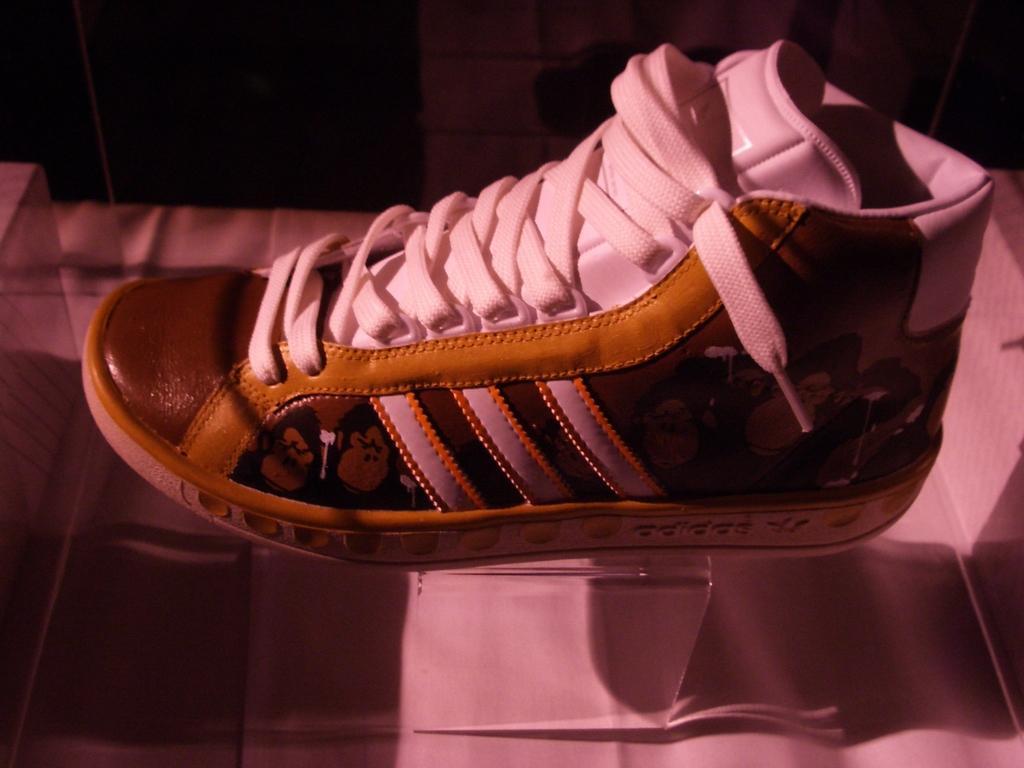Can you describe this image briefly? In this image we can see a shoe on the glass surface. 